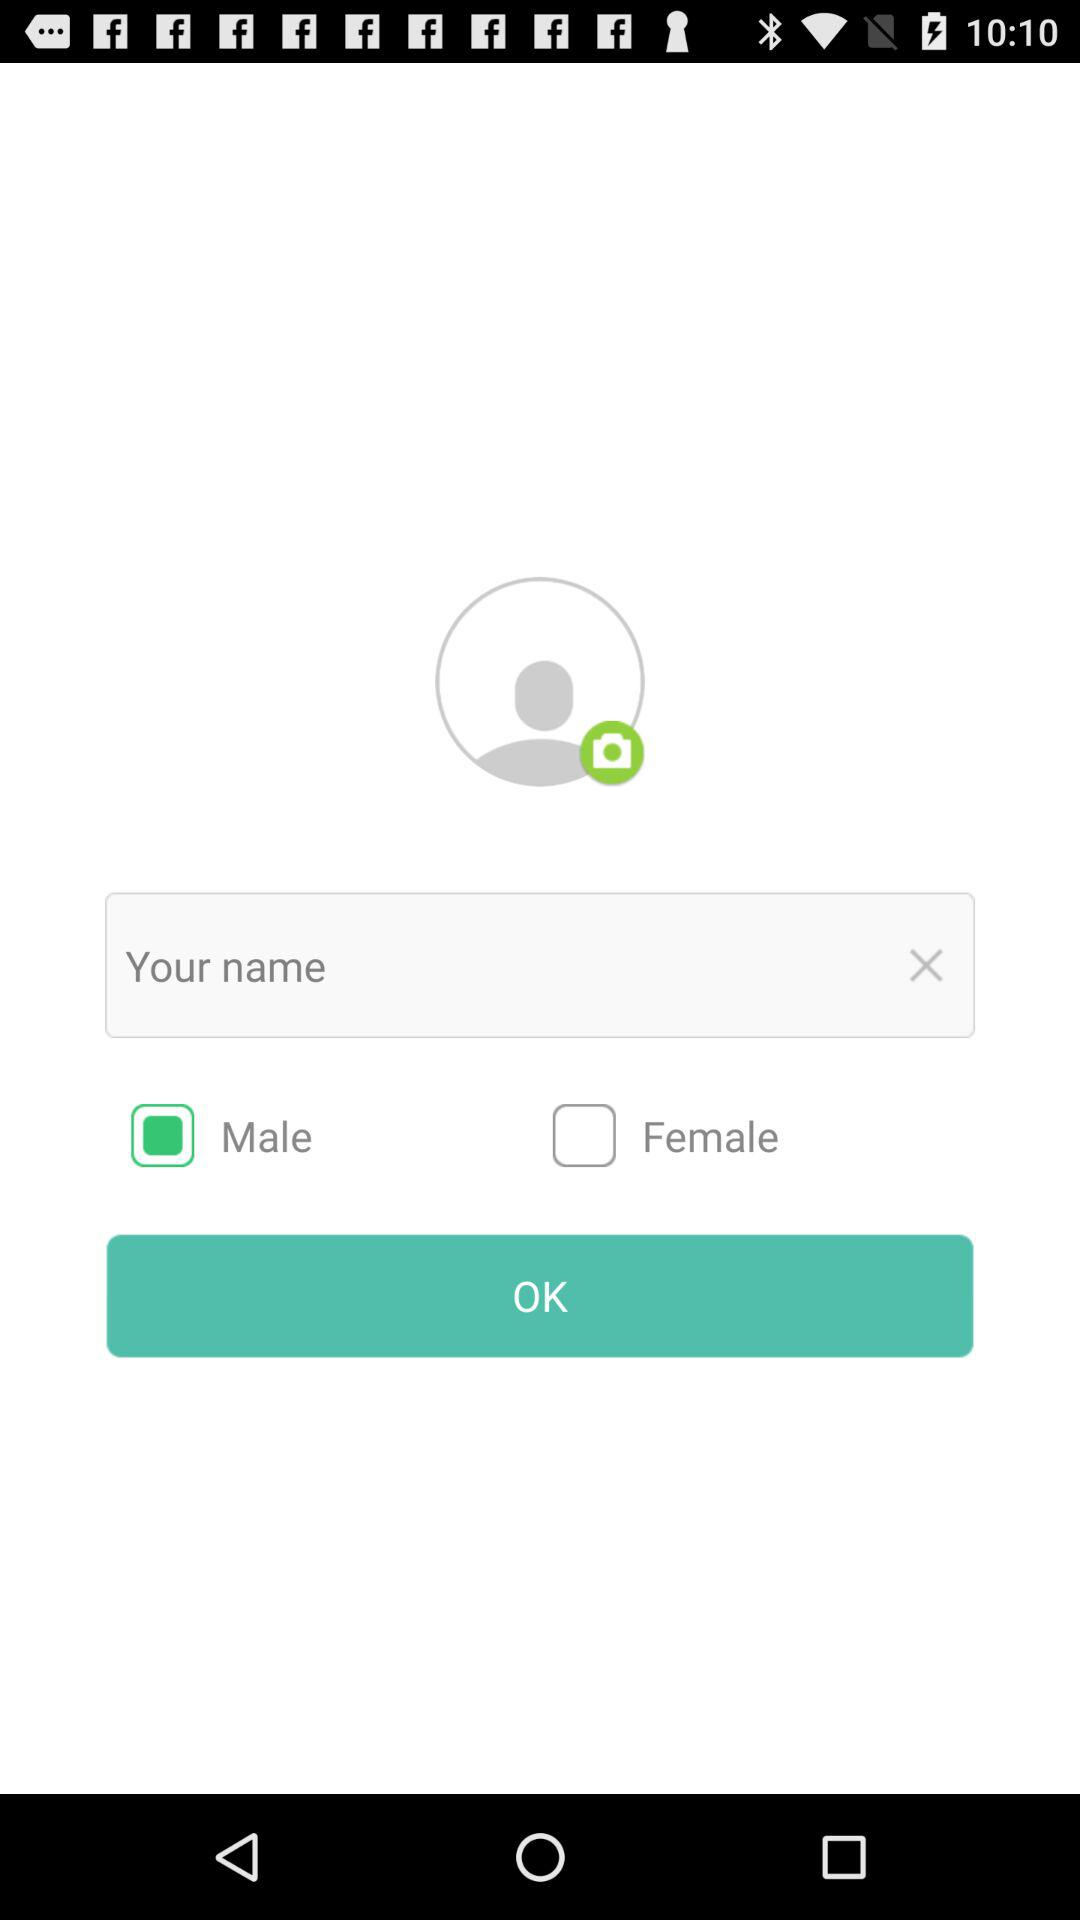What is the selected gender? The selected gender is male. 